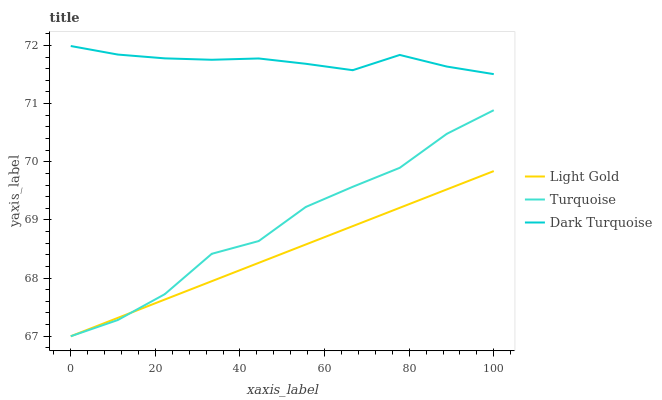Does Light Gold have the minimum area under the curve?
Answer yes or no. Yes. Does Dark Turquoise have the maximum area under the curve?
Answer yes or no. Yes. Does Turquoise have the minimum area under the curve?
Answer yes or no. No. Does Turquoise have the maximum area under the curve?
Answer yes or no. No. Is Light Gold the smoothest?
Answer yes or no. Yes. Is Turquoise the roughest?
Answer yes or no. Yes. Is Turquoise the smoothest?
Answer yes or no. No. Is Light Gold the roughest?
Answer yes or no. No. Does Turquoise have the highest value?
Answer yes or no. No. Is Light Gold less than Dark Turquoise?
Answer yes or no. Yes. Is Dark Turquoise greater than Turquoise?
Answer yes or no. Yes. Does Light Gold intersect Dark Turquoise?
Answer yes or no. No. 